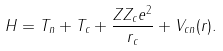<formula> <loc_0><loc_0><loc_500><loc_500>H = T _ { n } + T _ { c } + \frac { Z Z _ { c } e ^ { 2 } } { r _ { c } } + V _ { c n } ( r ) .</formula> 